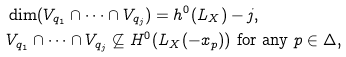<formula> <loc_0><loc_0><loc_500><loc_500>& \dim ( V _ { q _ { 1 } } \cap \cdots \cap V _ { q _ { j } } ) = h ^ { 0 } ( L _ { X } ) - j , \\ & V _ { q _ { 1 } } \cap \cdots \cap V _ { q _ { j } } \not \subseteq H ^ { 0 } ( L _ { X } ( - x _ { p } ) ) \text { for any $p\in\Delta$,}</formula> 